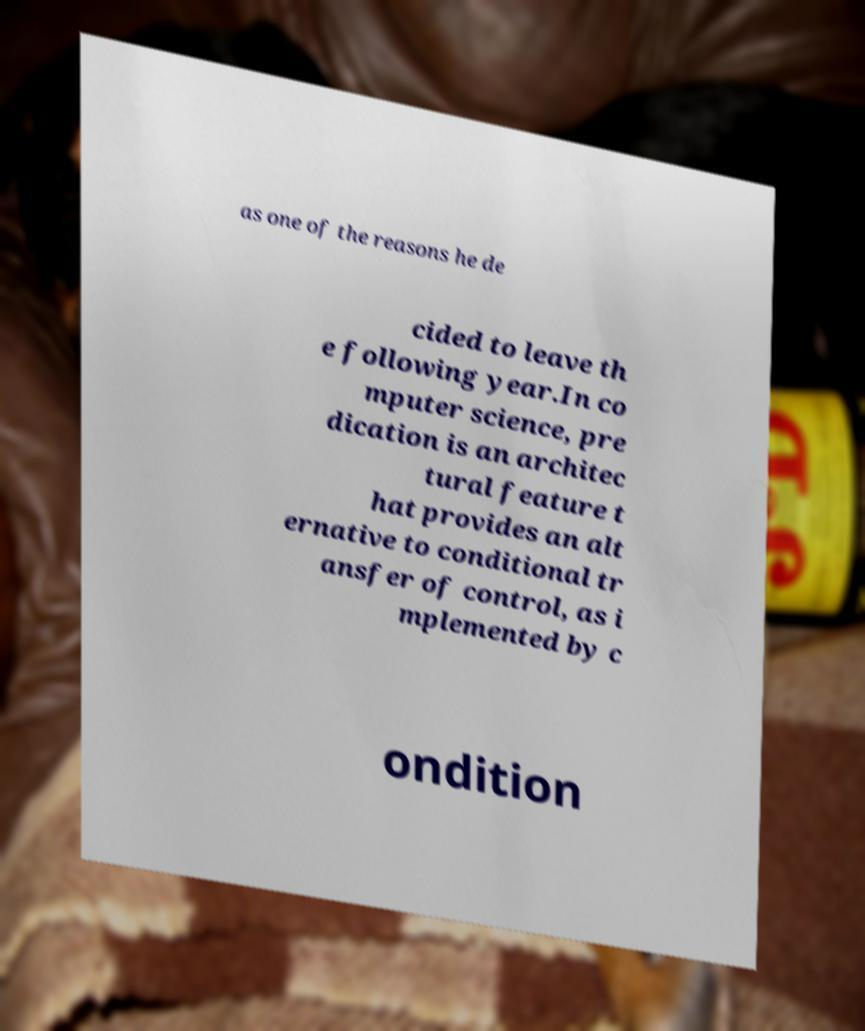What messages or text are displayed in this image? I need them in a readable, typed format. as one of the reasons he de cided to leave th e following year.In co mputer science, pre dication is an architec tural feature t hat provides an alt ernative to conditional tr ansfer of control, as i mplemented by c ondition 